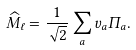Convert formula to latex. <formula><loc_0><loc_0><loc_500><loc_500>\widehat { M } _ { \ell } = \frac { 1 } { \sqrt { 2 } } \sum _ { a } v _ { a } \Pi _ { a } .</formula> 